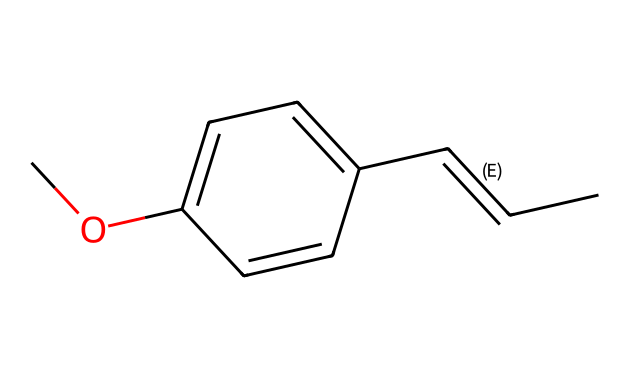What is the molecular formula of this compound? To determine the molecular formula, count the number of each type of atom in the SMILES representation. The structure contains 10 carbon (C) atoms, 10 hydrogen (H) atoms, and 1 oxygen (O) atom, leading to the formula C10H10O.
Answer: C10H10O How many rings are present in this aromatic compound? Analyzing the structure, the presence of benzene rings can be identified. In this SMILES notation, there is one aromatic ring which is part of the molecule (the "c" characters indicate aromatic carbon atoms).
Answer: 1 What type of functional group is represented in this compound? The SMILES shows "CO", indicating the presence of an ether or alcohol group. In this specific case, it's a methoxy group (-OCH3), which is a functional group related to ethers.
Answer: methoxy What is the degree of unsaturation in this molecule? Each ring and double bond contributes to the degree of unsaturation. The formula for calculating it is (1 + 1/2(2C + 2 + N - H - X)). For the given molecule, it has a total of 4 degrees of unsaturation due to its benzene ring and double bond.
Answer: 4 What type of isomerism is exhibited by this compound? This compound can show geometric isomerism due to the presence of a double bond (/C=C/) in the structure, which allows for cis-trans or E-Z isomerism.
Answer: geometric Does this compound exhibit aromaticity? Given that the molecule contains a six-membered cyclic structure with alternating double bonds (like a benzene ring), it fulfills Huckel's rule (4n + 2 π electrons) with 6 π electrons, confirming its aromatic nature.
Answer: yes 